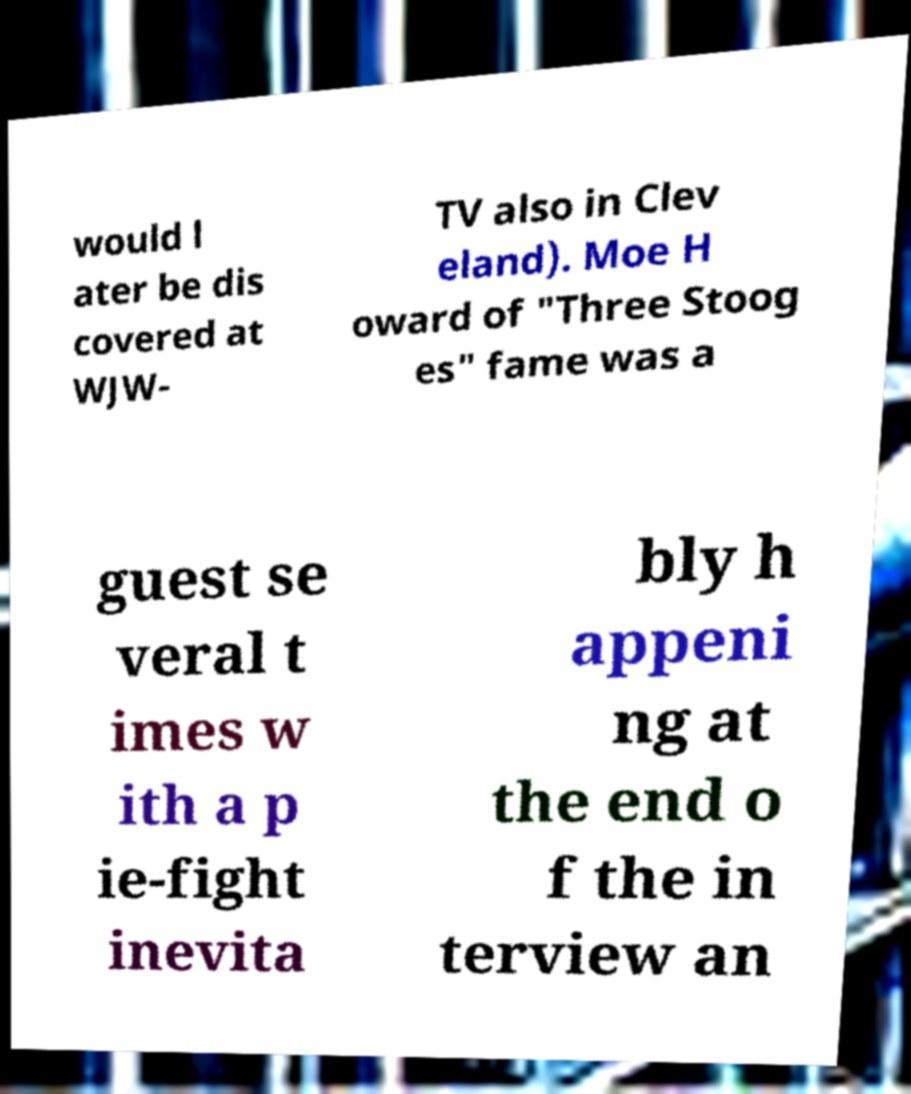I need the written content from this picture converted into text. Can you do that? would l ater be dis covered at WJW- TV also in Clev eland). Moe H oward of "Three Stoog es" fame was a guest se veral t imes w ith a p ie-fight inevita bly h appeni ng at the end o f the in terview an 